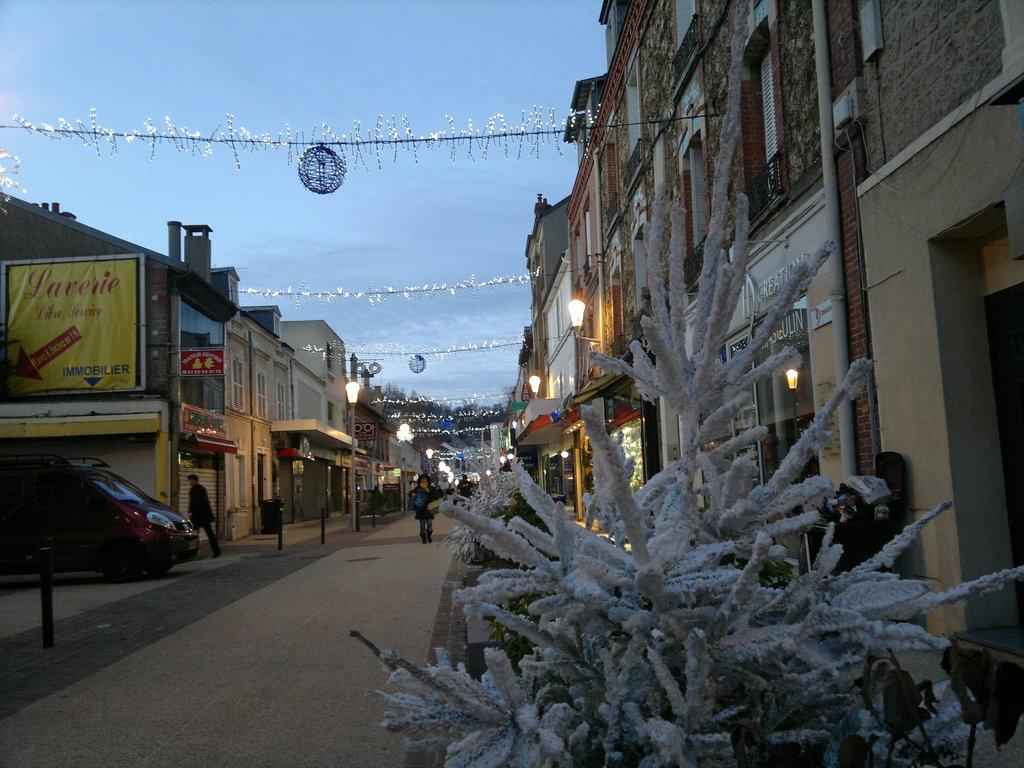Who or what can be seen in the image? There are people in the image. What else is present in the image besides people? There are plants, metal rods, a vehicle, and various background elements such as buildings, hoardings, poles, and lights. Can you describe the plants in the image? The plants in the image are not specified, but they are present. What type of vehicle is visible in the image? The type of vehicle is not specified, but it is present in the image. What is the purpose of the cork in the image? There is no cork present in the image. Who needs to approve the actions of the people in the image? The image does not provide information about who needs to approve the actions of the people. 